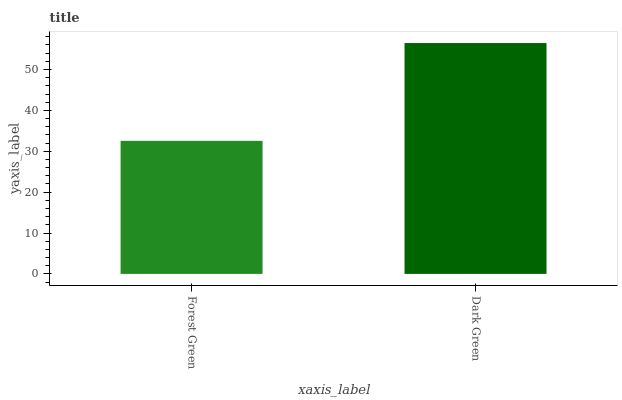Is Forest Green the minimum?
Answer yes or no. Yes. Is Dark Green the maximum?
Answer yes or no. Yes. Is Dark Green the minimum?
Answer yes or no. No. Is Dark Green greater than Forest Green?
Answer yes or no. Yes. Is Forest Green less than Dark Green?
Answer yes or no. Yes. Is Forest Green greater than Dark Green?
Answer yes or no. No. Is Dark Green less than Forest Green?
Answer yes or no. No. Is Dark Green the high median?
Answer yes or no. Yes. Is Forest Green the low median?
Answer yes or no. Yes. Is Forest Green the high median?
Answer yes or no. No. Is Dark Green the low median?
Answer yes or no. No. 